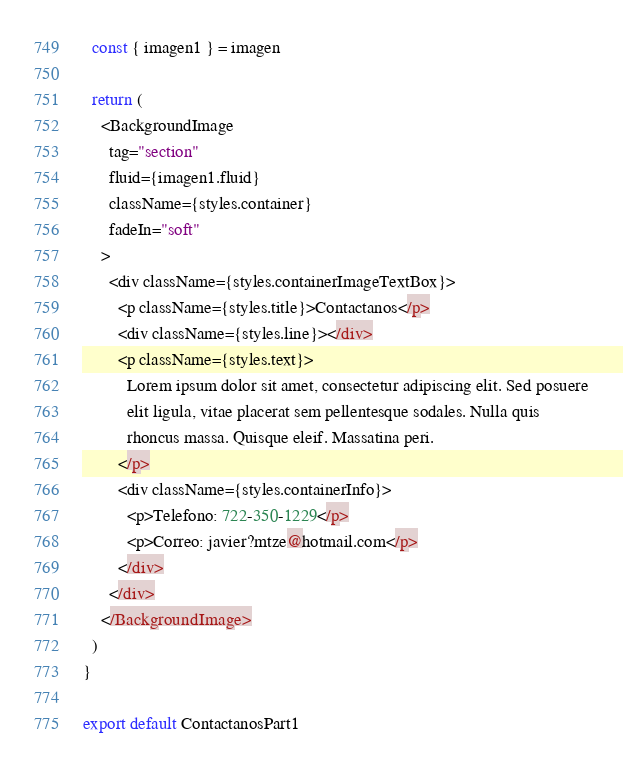Convert code to text. <code><loc_0><loc_0><loc_500><loc_500><_JavaScript_>  const { imagen1 } = imagen

  return (
    <BackgroundImage
      tag="section"
      fluid={imagen1.fluid}
      className={styles.container}
      fadeIn="soft"
    >
      <div className={styles.containerImageTextBox}>
        <p className={styles.title}>Contactanos</p>
        <div className={styles.line}></div>
        <p className={styles.text}>
          Lorem ipsum dolor sit amet, consectetur adipiscing elit. Sed posuere
          elit ligula, vitae placerat sem pellentesque sodales. Nulla quis
          rhoncus massa. Quisque eleif. Massatina peri.
        </p>
        <div className={styles.containerInfo}>
          <p>Telefono: 722-350-1229</p>
          <p>Correo: javier?mtze@hotmail.com</p>
        </div>
      </div>
    </BackgroundImage>
  )
}

export default ContactanosPart1
</code> 